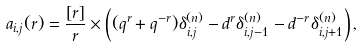Convert formula to latex. <formula><loc_0><loc_0><loc_500><loc_500>a _ { i , j } ( r ) = \frac { [ r ] } { r } \times \left ( ( q ^ { r } + q ^ { - r } ) \delta ^ { ( n ) } _ { i , j } - d ^ { r } \delta ^ { ( n ) } _ { i , j - 1 } - d ^ { - r } \delta ^ { ( n ) } _ { i , j + 1 } \right ) ,</formula> 